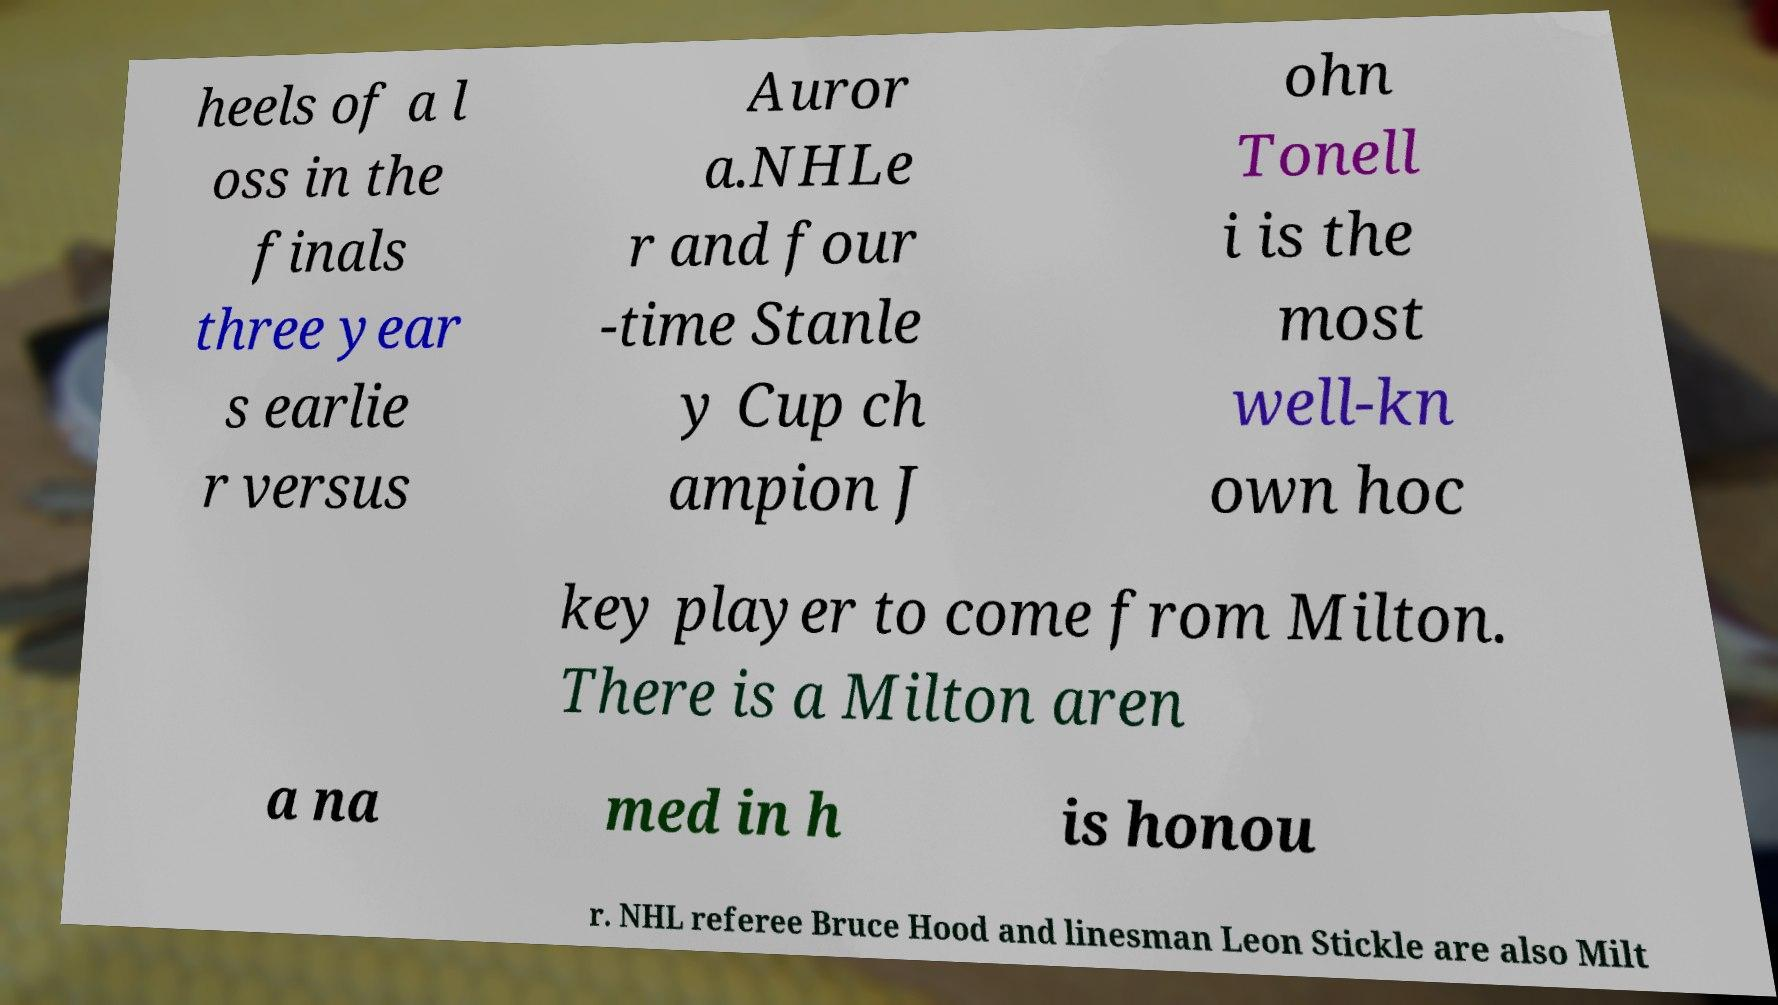Could you extract and type out the text from this image? heels of a l oss in the finals three year s earlie r versus Auror a.NHLe r and four -time Stanle y Cup ch ampion J ohn Tonell i is the most well-kn own hoc key player to come from Milton. There is a Milton aren a na med in h is honou r. NHL referee Bruce Hood and linesman Leon Stickle are also Milt 